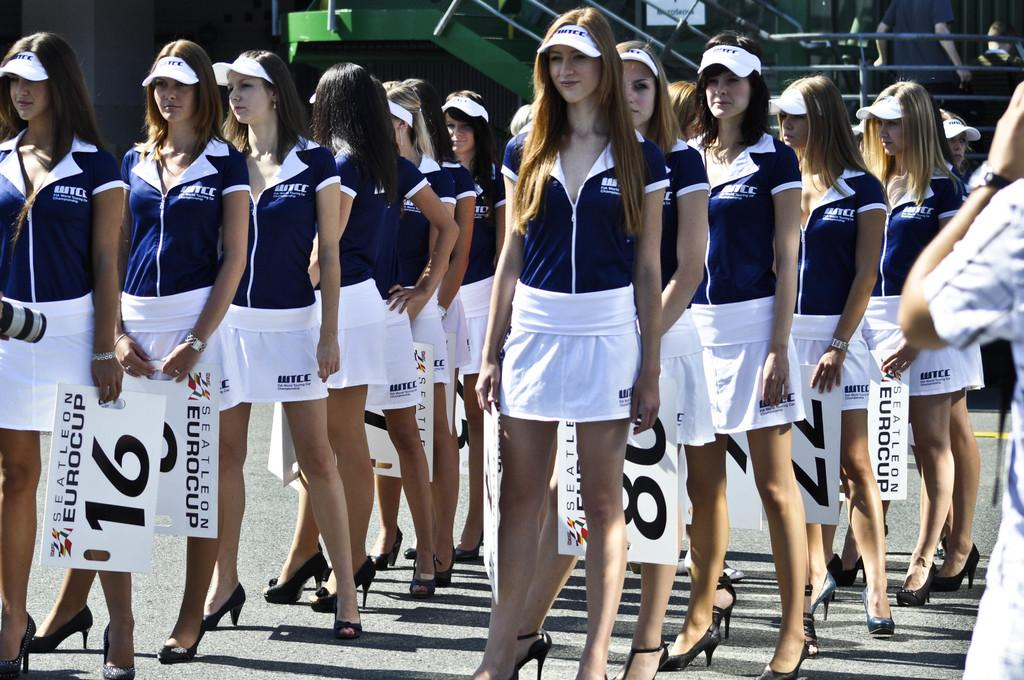What can be seen in the image? There is a group of women in the image. What are the women wearing? The women are wearing caps. What are the women holding? The women are holding number boards. Where are the women standing? The women are standing on the road. What can be seen in the background of the image? There are rods and people visible in the background. What color crayon is the girl holding in the image? There are no girls or crayons present in the image; it features a group of women holding number boards. 